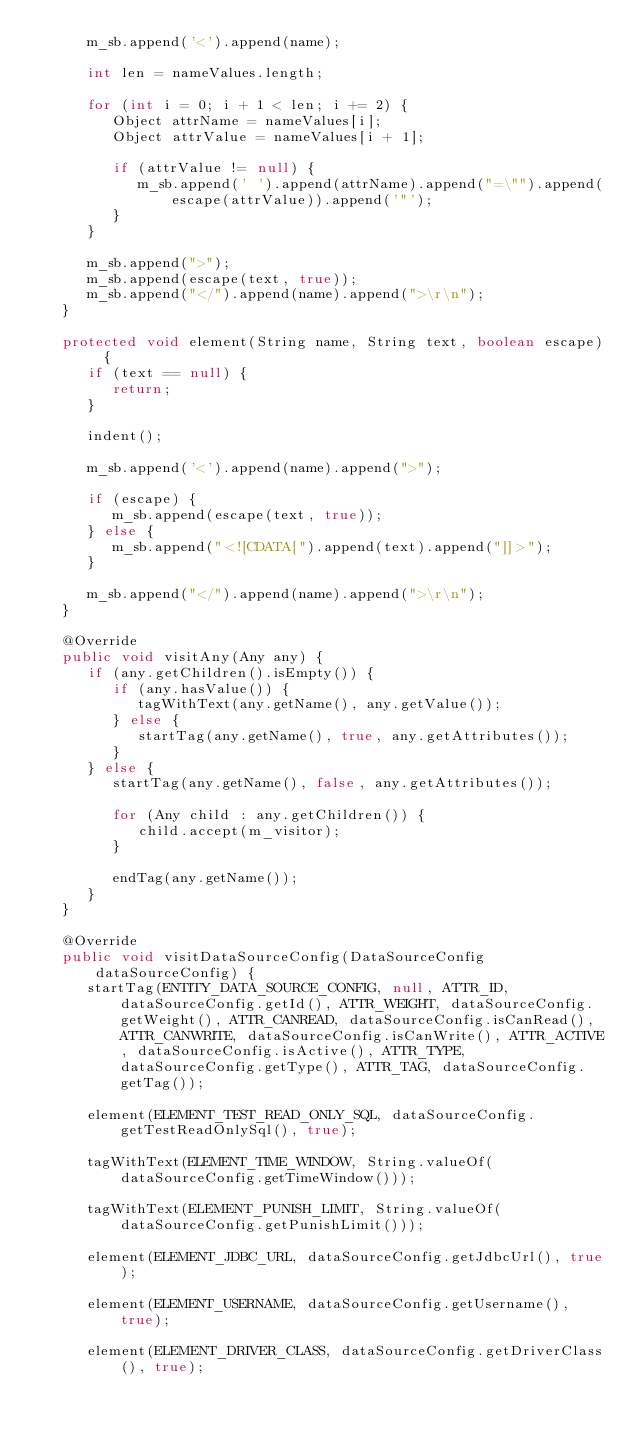Convert code to text. <code><loc_0><loc_0><loc_500><loc_500><_Java_>      m_sb.append('<').append(name);

      int len = nameValues.length;

      for (int i = 0; i + 1 < len; i += 2) {
         Object attrName = nameValues[i];
         Object attrValue = nameValues[i + 1];

         if (attrValue != null) {
            m_sb.append(' ').append(attrName).append("=\"").append(escape(attrValue)).append('"');
         }
      }

      m_sb.append(">");
      m_sb.append(escape(text, true));
      m_sb.append("</").append(name).append(">\r\n");
   }

   protected void element(String name, String text, boolean escape) {
      if (text == null) {
         return;
      }
      
      indent();
      
      m_sb.append('<').append(name).append(">");
      
      if (escape) {
         m_sb.append(escape(text, true));
      } else {
         m_sb.append("<![CDATA[").append(text).append("]]>");
      }
      
      m_sb.append("</").append(name).append(">\r\n");
   }

   @Override
   public void visitAny(Any any) {
      if (any.getChildren().isEmpty()) {
         if (any.hasValue()) {
            tagWithText(any.getName(), any.getValue());
         } else {
            startTag(any.getName(), true, any.getAttributes());
         }
      } else {
         startTag(any.getName(), false, any.getAttributes());

         for (Any child : any.getChildren()) {
            child.accept(m_visitor);
         }

         endTag(any.getName());
      }
   }

   @Override
   public void visitDataSourceConfig(DataSourceConfig dataSourceConfig) {
      startTag(ENTITY_DATA_SOURCE_CONFIG, null, ATTR_ID, dataSourceConfig.getId(), ATTR_WEIGHT, dataSourceConfig.getWeight(), ATTR_CANREAD, dataSourceConfig.isCanRead(), ATTR_CANWRITE, dataSourceConfig.isCanWrite(), ATTR_ACTIVE, dataSourceConfig.isActive(), ATTR_TYPE, dataSourceConfig.getType(), ATTR_TAG, dataSourceConfig.getTag());

      element(ELEMENT_TEST_READ_ONLY_SQL, dataSourceConfig.getTestReadOnlySql(), true);

      tagWithText(ELEMENT_TIME_WINDOW, String.valueOf(dataSourceConfig.getTimeWindow()));

      tagWithText(ELEMENT_PUNISH_LIMIT, String.valueOf(dataSourceConfig.getPunishLimit()));

      element(ELEMENT_JDBC_URL, dataSourceConfig.getJdbcUrl(), true);

      element(ELEMENT_USERNAME, dataSourceConfig.getUsername(), true);

      element(ELEMENT_DRIVER_CLASS, dataSourceConfig.getDriverClass(), true);
</code> 